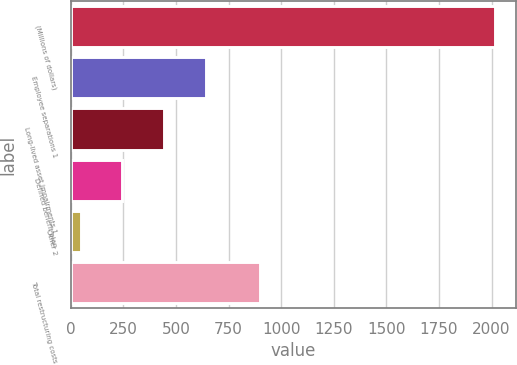Convert chart to OTSL. <chart><loc_0><loc_0><loc_500><loc_500><bar_chart><fcel>(Millions of dollars)<fcel>Employee separations 1<fcel>Long-lived asset impairments 1<fcel>Defined benefit plan<fcel>Other 2<fcel>Total restructuring costs<nl><fcel>2015<fcel>641<fcel>441.4<fcel>244.7<fcel>48<fcel>898<nl></chart> 